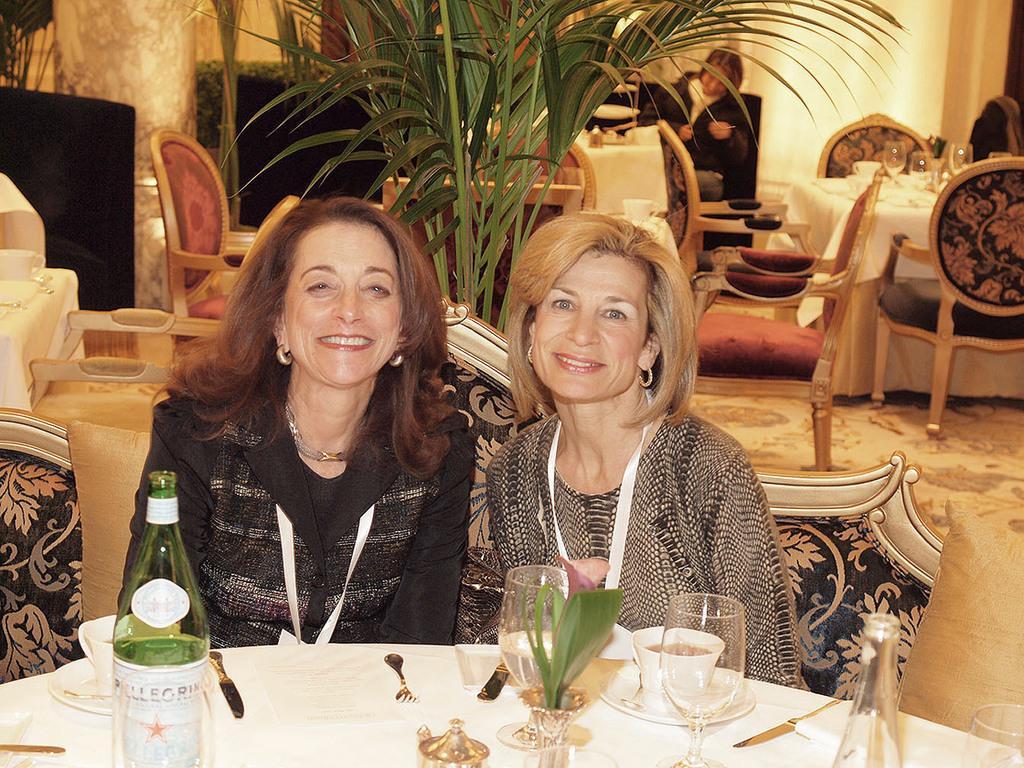In one or two sentences, can you explain what this image depicts? In this image we can see a few people, two of them are sitting on the chairs, there are tables, chairs, on the tables, there is a cloth, glasses, bottles, cups, forks spoons, also we can see the house plant, and the wall. 